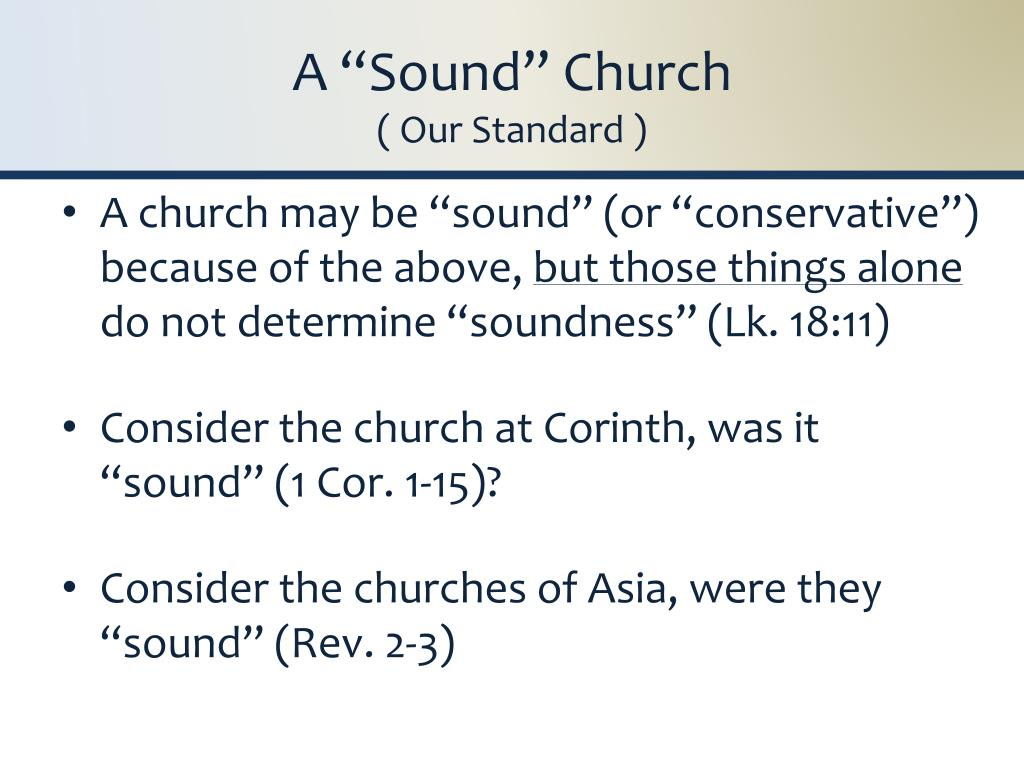Based on the information provided on the slide, what biblical criteria might the presenter be using to define the concept of a 'sound' church, and how do the provided scripture references contribute to this definition? The biblical criteria for defining a 'sound' church, as suggested by the slide, appear to be linked to the concept of conservatism, or perhaps adherence to certain principles or doctrines. The presenter points out that being 'sound' or 'conservative' is not solely determined by “the above,” which might refer to previously mentioned criteria in the presentation. The scripture references (Luke 18:11, 1 Corinthians 1-15, and Revelation 2-3) are likely used to illustrate examples or counterexamples of what the presenter considers 'soundness' in a church. Luke 18:11 might be referenced to discuss self-righteousness as an unsound quality, whereas the letters to the Corinthians and the churches of Asia might discuss issues related to practices and beliefs that either align with or deviate from what is considered 'sound' by the presenter’s standards. 